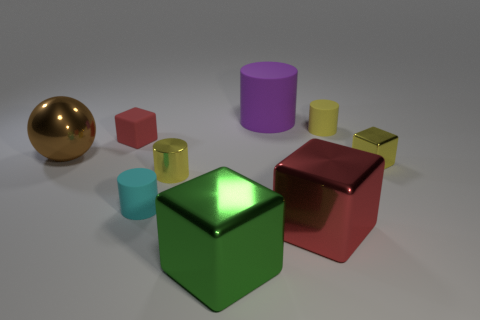How many things are cyan objects or small things to the left of the tiny yellow cube?
Ensure brevity in your answer.  4. What is the shape of the small rubber object that is the same color as the small shiny cylinder?
Your answer should be very brief. Cylinder. How many metal objects have the same size as the cyan rubber cylinder?
Provide a short and direct response. 2. What number of gray things are shiny cylinders or metallic balls?
Your response must be concise. 0. There is a yellow thing that is behind the metallic cube behind the cyan rubber cylinder; what is its shape?
Make the answer very short. Cylinder. The brown thing that is the same size as the purple thing is what shape?
Keep it short and to the point. Sphere. Is there a cube that has the same color as the large matte object?
Ensure brevity in your answer.  No. Are there the same number of big brown metallic objects on the left side of the metallic sphere and large red objects that are right of the tiny yellow rubber thing?
Your answer should be compact. Yes. Does the cyan thing have the same shape as the shiny thing behind the yellow metallic cube?
Make the answer very short. No. How many other things are the same material as the cyan object?
Keep it short and to the point. 3. 